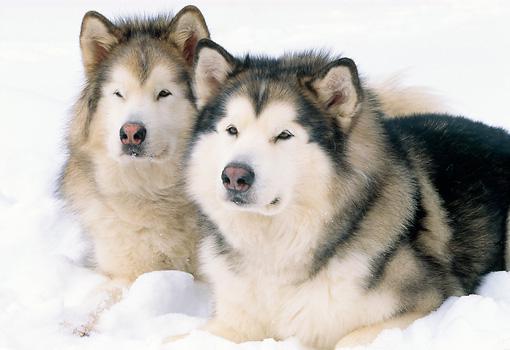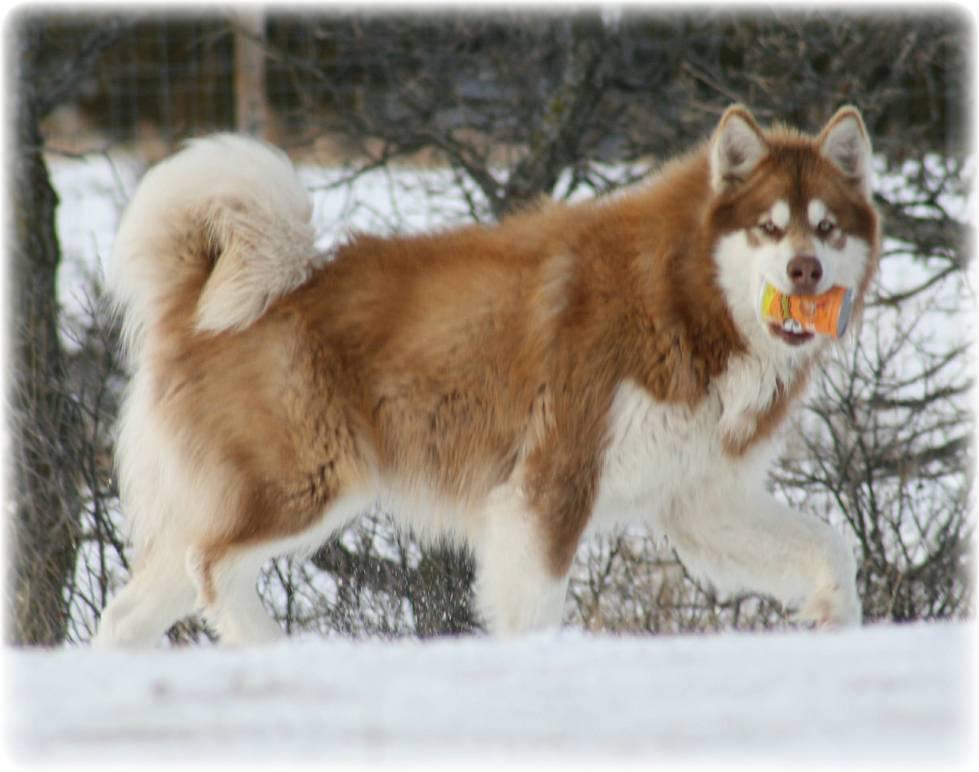The first image is the image on the left, the second image is the image on the right. Considering the images on both sides, is "An image shows two adult huskies reclining side-by-side in the snow, with a dusting of snow on their fur." valid? Answer yes or no. Yes. The first image is the image on the left, the second image is the image on the right. For the images shown, is this caption "There is one dog who is not in the snow." true? Answer yes or no. No. 